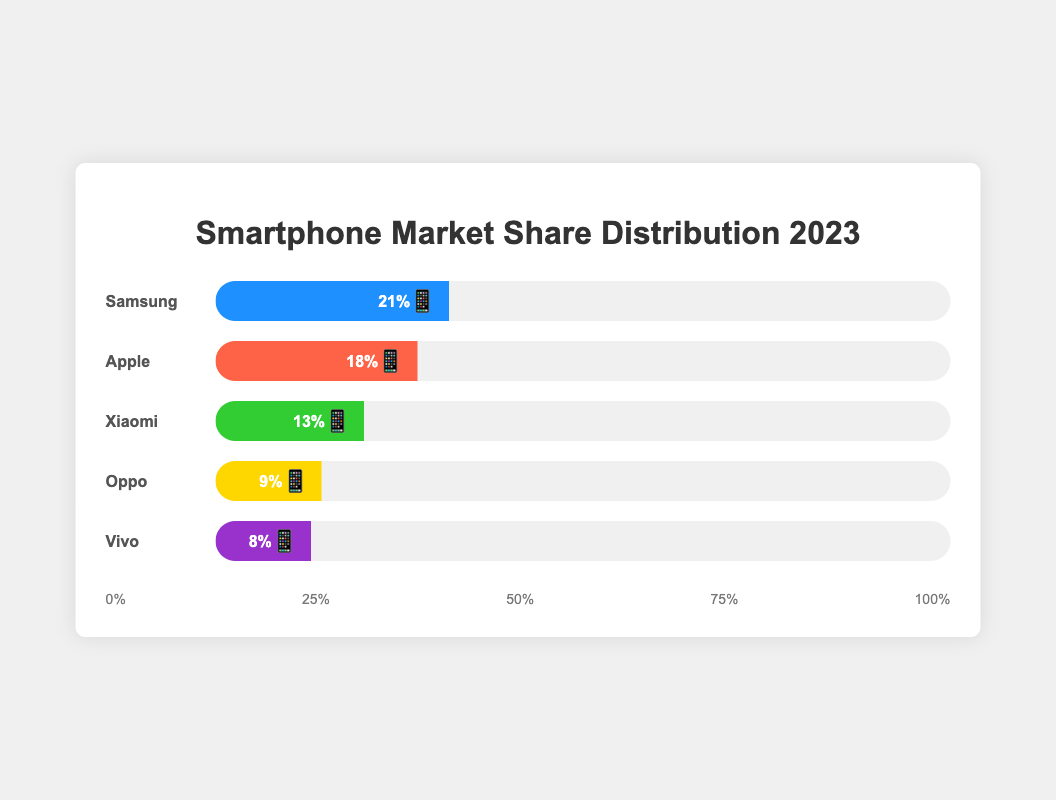What is the title of this figure? The title is located at the top of the figure and is prominently displayed in a larger font size.
Answer: Smartphone Market Share Distribution 2023 Which competitor has the highest market share? The figure shows the market share of each competitor as a horizontal bar, with Samsung having the largest blue bar, labeled with 21%.
Answer: Samsung What is the combined market share of Oppo and Vivo? From the figure, Oppo's market share is shown as 9% and Vivo's is shown as 8%. Summing these values: 9% + 8% = 17%
Answer: 17% Which competitor has a market share closest to 25%? The only competitor with a market share close to 25% is Apple, which is shown with a market share of 18%.
Answer: Apple How does Xiaomi’s market share compare to Apple’s market share? Xiaomi’s market share is labeled as 13% and Apple’s is labeled as 18%. Subtracting these values: 18% - 13% = 5%, showing that Apple has 5% more market share than Xiaomi.
Answer: Apple has 5% more market share than Xiaomi What is the difference in market share between the competitor with the smallest share and the competitor with the largest share? Vivo has the smallest market share at 8% and Samsung has the largest share at 21%. The difference is: 21% - 8% = 13%
Answer: 13% How many competitors have a market share greater than 10%? From the figure, Samsung (21%), Apple (18%), and Xiaomi (13%) all have market shares greater than 10%, totaling 3 competitors.
Answer: 3 competitors What is the total market share of the top two competitors combined? The market shares of Samsung and Apple are 21% and 18% respectively. Summing these values: 21% + 18% = 39%
Answer: 39% Which competitor's market share is visually the second smallest? Based on the size of the horizontal bars, Vivo’s (8%) market share is the smallest and Oppo’s (9%) is the second smallest.
Answer: Oppo What percentage of the market is held by all competitors not listed in the top 5? The figure indicates that the total market share of the top 5 competitors is 69%, leaving the remainder of 100% - 69% = 31% for others.
Answer: 31% 